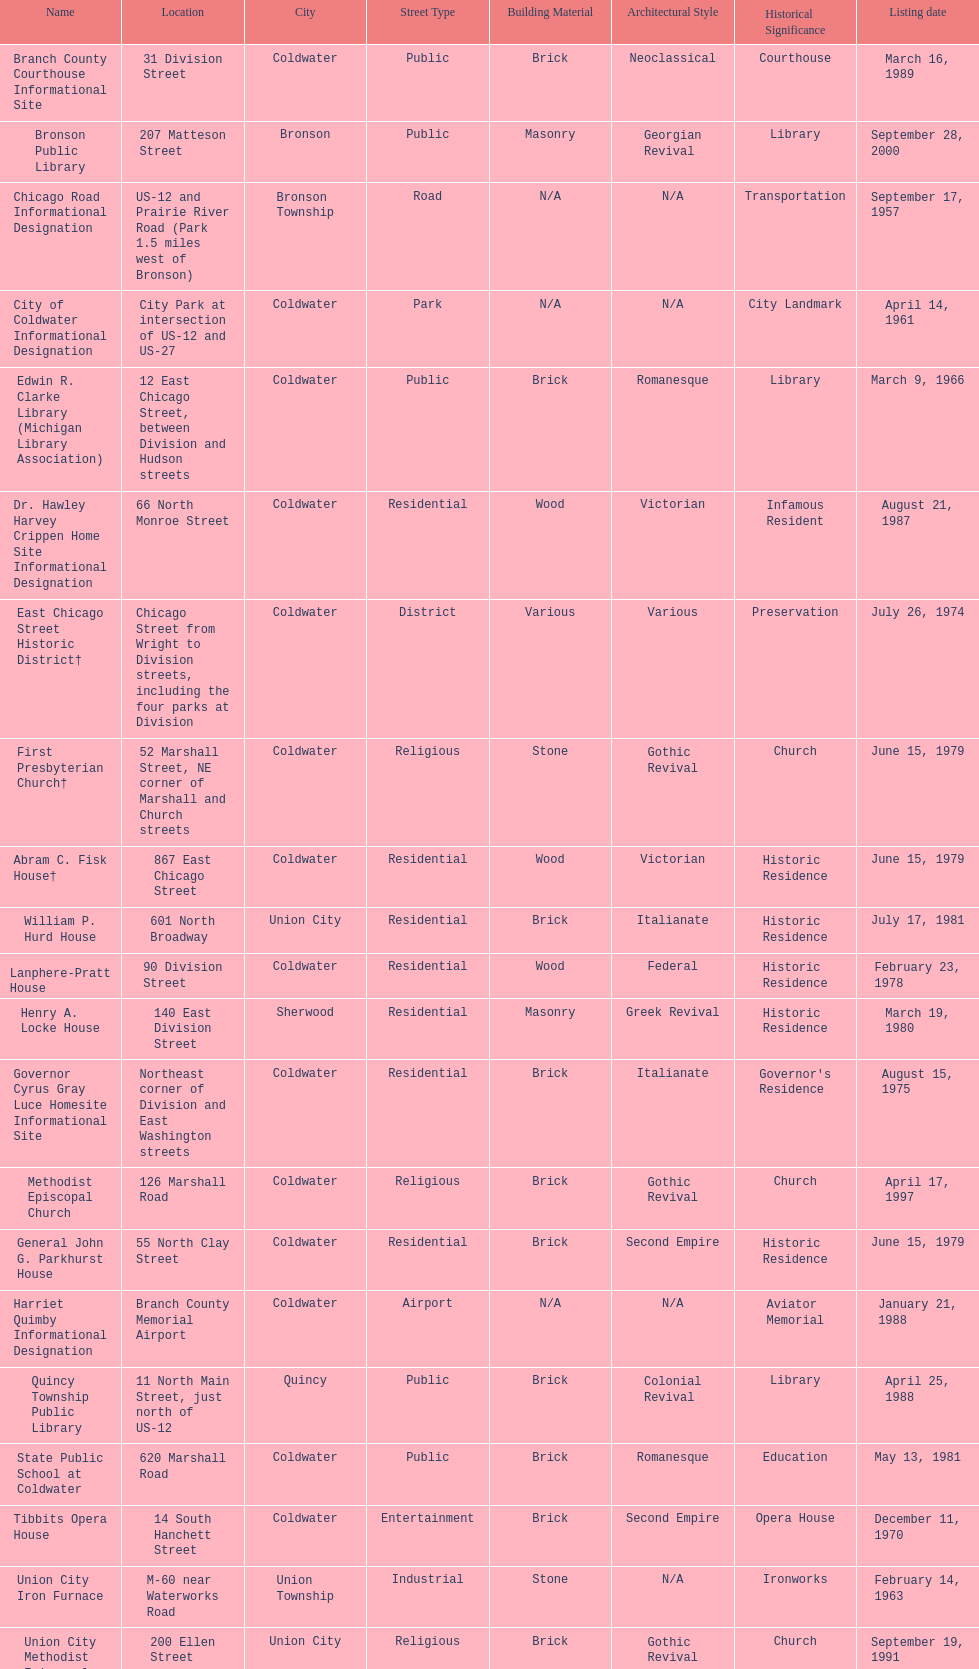How many historic sites are listed in coldwater? 15. 